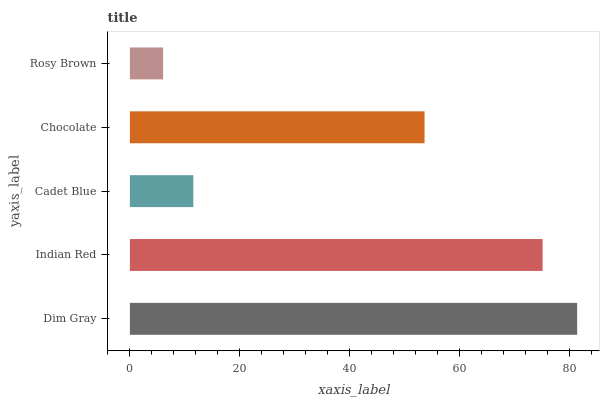Is Rosy Brown the minimum?
Answer yes or no. Yes. Is Dim Gray the maximum?
Answer yes or no. Yes. Is Indian Red the minimum?
Answer yes or no. No. Is Indian Red the maximum?
Answer yes or no. No. Is Dim Gray greater than Indian Red?
Answer yes or no. Yes. Is Indian Red less than Dim Gray?
Answer yes or no. Yes. Is Indian Red greater than Dim Gray?
Answer yes or no. No. Is Dim Gray less than Indian Red?
Answer yes or no. No. Is Chocolate the high median?
Answer yes or no. Yes. Is Chocolate the low median?
Answer yes or no. Yes. Is Cadet Blue the high median?
Answer yes or no. No. Is Dim Gray the low median?
Answer yes or no. No. 